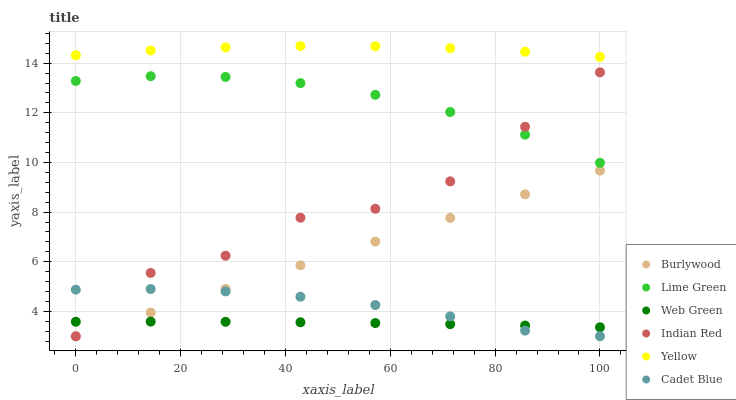Does Web Green have the minimum area under the curve?
Answer yes or no. Yes. Does Yellow have the maximum area under the curve?
Answer yes or no. Yes. Does Burlywood have the minimum area under the curve?
Answer yes or no. No. Does Burlywood have the maximum area under the curve?
Answer yes or no. No. Is Burlywood the smoothest?
Answer yes or no. Yes. Is Indian Red the roughest?
Answer yes or no. Yes. Is Yellow the smoothest?
Answer yes or no. No. Is Yellow the roughest?
Answer yes or no. No. Does Cadet Blue have the lowest value?
Answer yes or no. Yes. Does Yellow have the lowest value?
Answer yes or no. No. Does Yellow have the highest value?
Answer yes or no. Yes. Does Burlywood have the highest value?
Answer yes or no. No. Is Web Green less than Lime Green?
Answer yes or no. Yes. Is Lime Green greater than Cadet Blue?
Answer yes or no. Yes. Does Burlywood intersect Indian Red?
Answer yes or no. Yes. Is Burlywood less than Indian Red?
Answer yes or no. No. Is Burlywood greater than Indian Red?
Answer yes or no. No. Does Web Green intersect Lime Green?
Answer yes or no. No. 